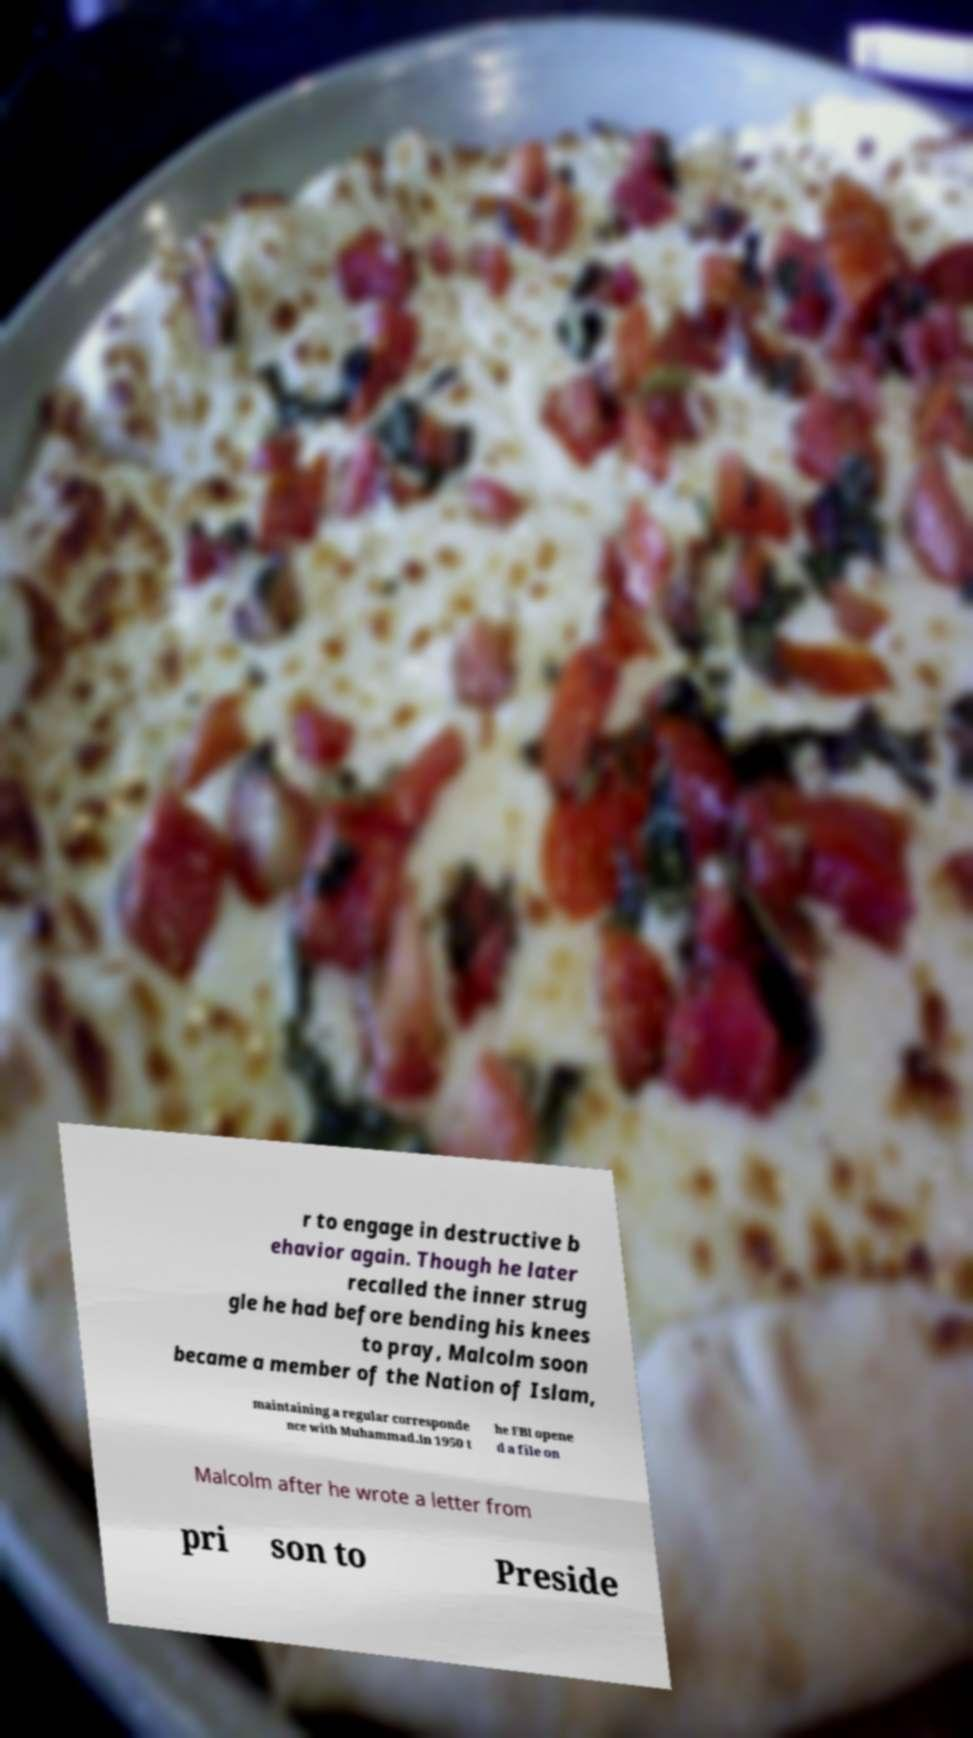Please read and relay the text visible in this image. What does it say? r to engage in destructive b ehavior again. Though he later recalled the inner strug gle he had before bending his knees to pray, Malcolm soon became a member of the Nation of Islam, maintaining a regular corresponde nce with Muhammad.In 1950 t he FBI opene d a file on Malcolm after he wrote a letter from pri son to Preside 